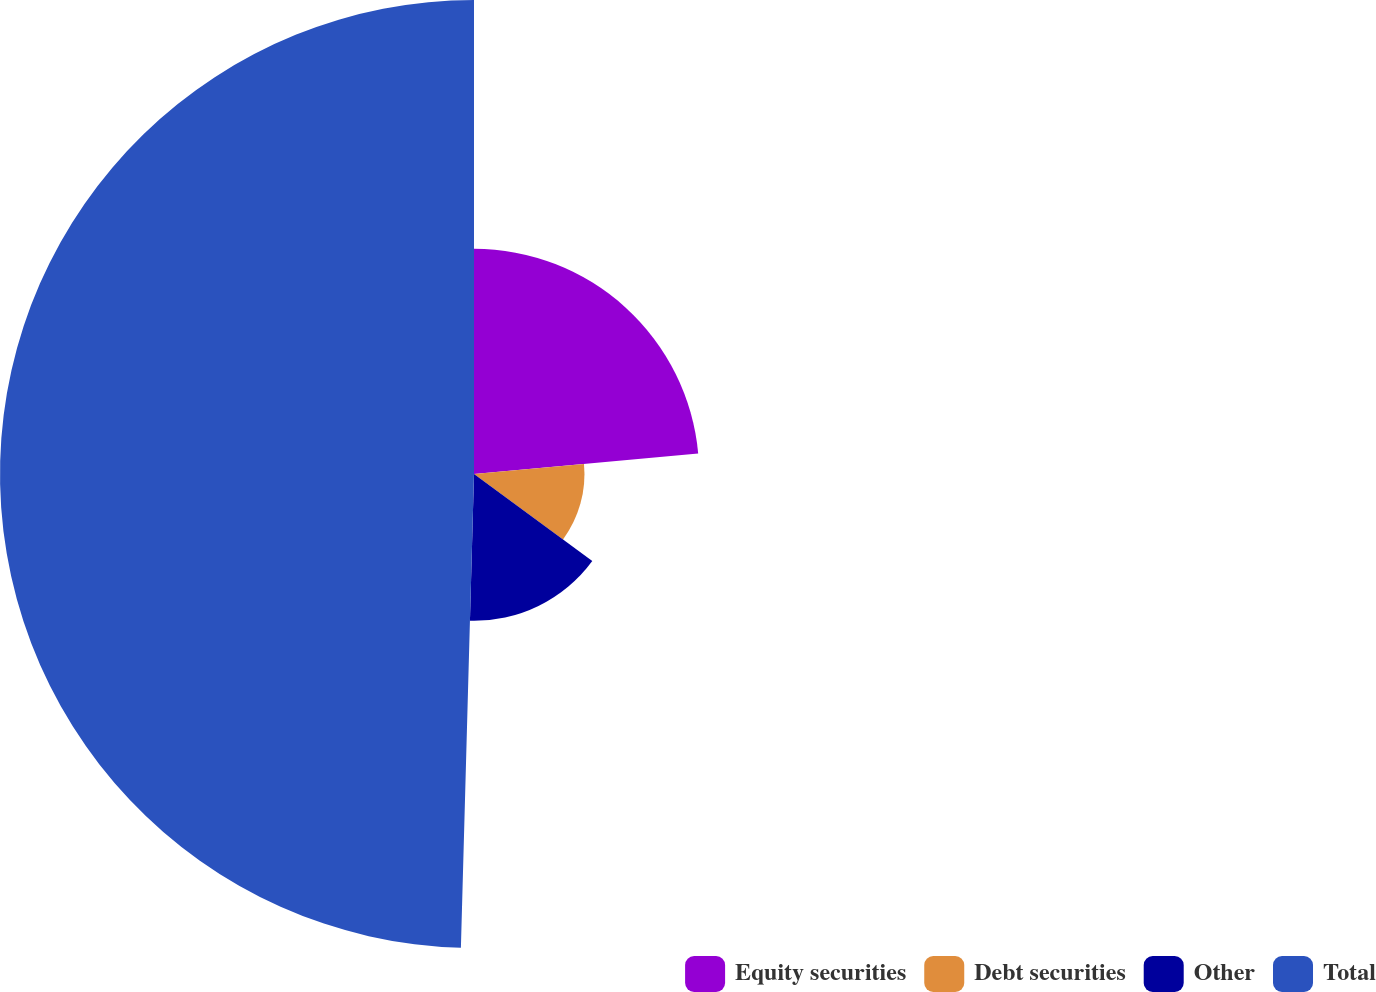Convert chart. <chart><loc_0><loc_0><loc_500><loc_500><pie_chart><fcel>Equity securities<fcel>Debt securities<fcel>Other<fcel>Total<nl><fcel>23.54%<fcel>11.55%<fcel>15.35%<fcel>49.56%<nl></chart> 